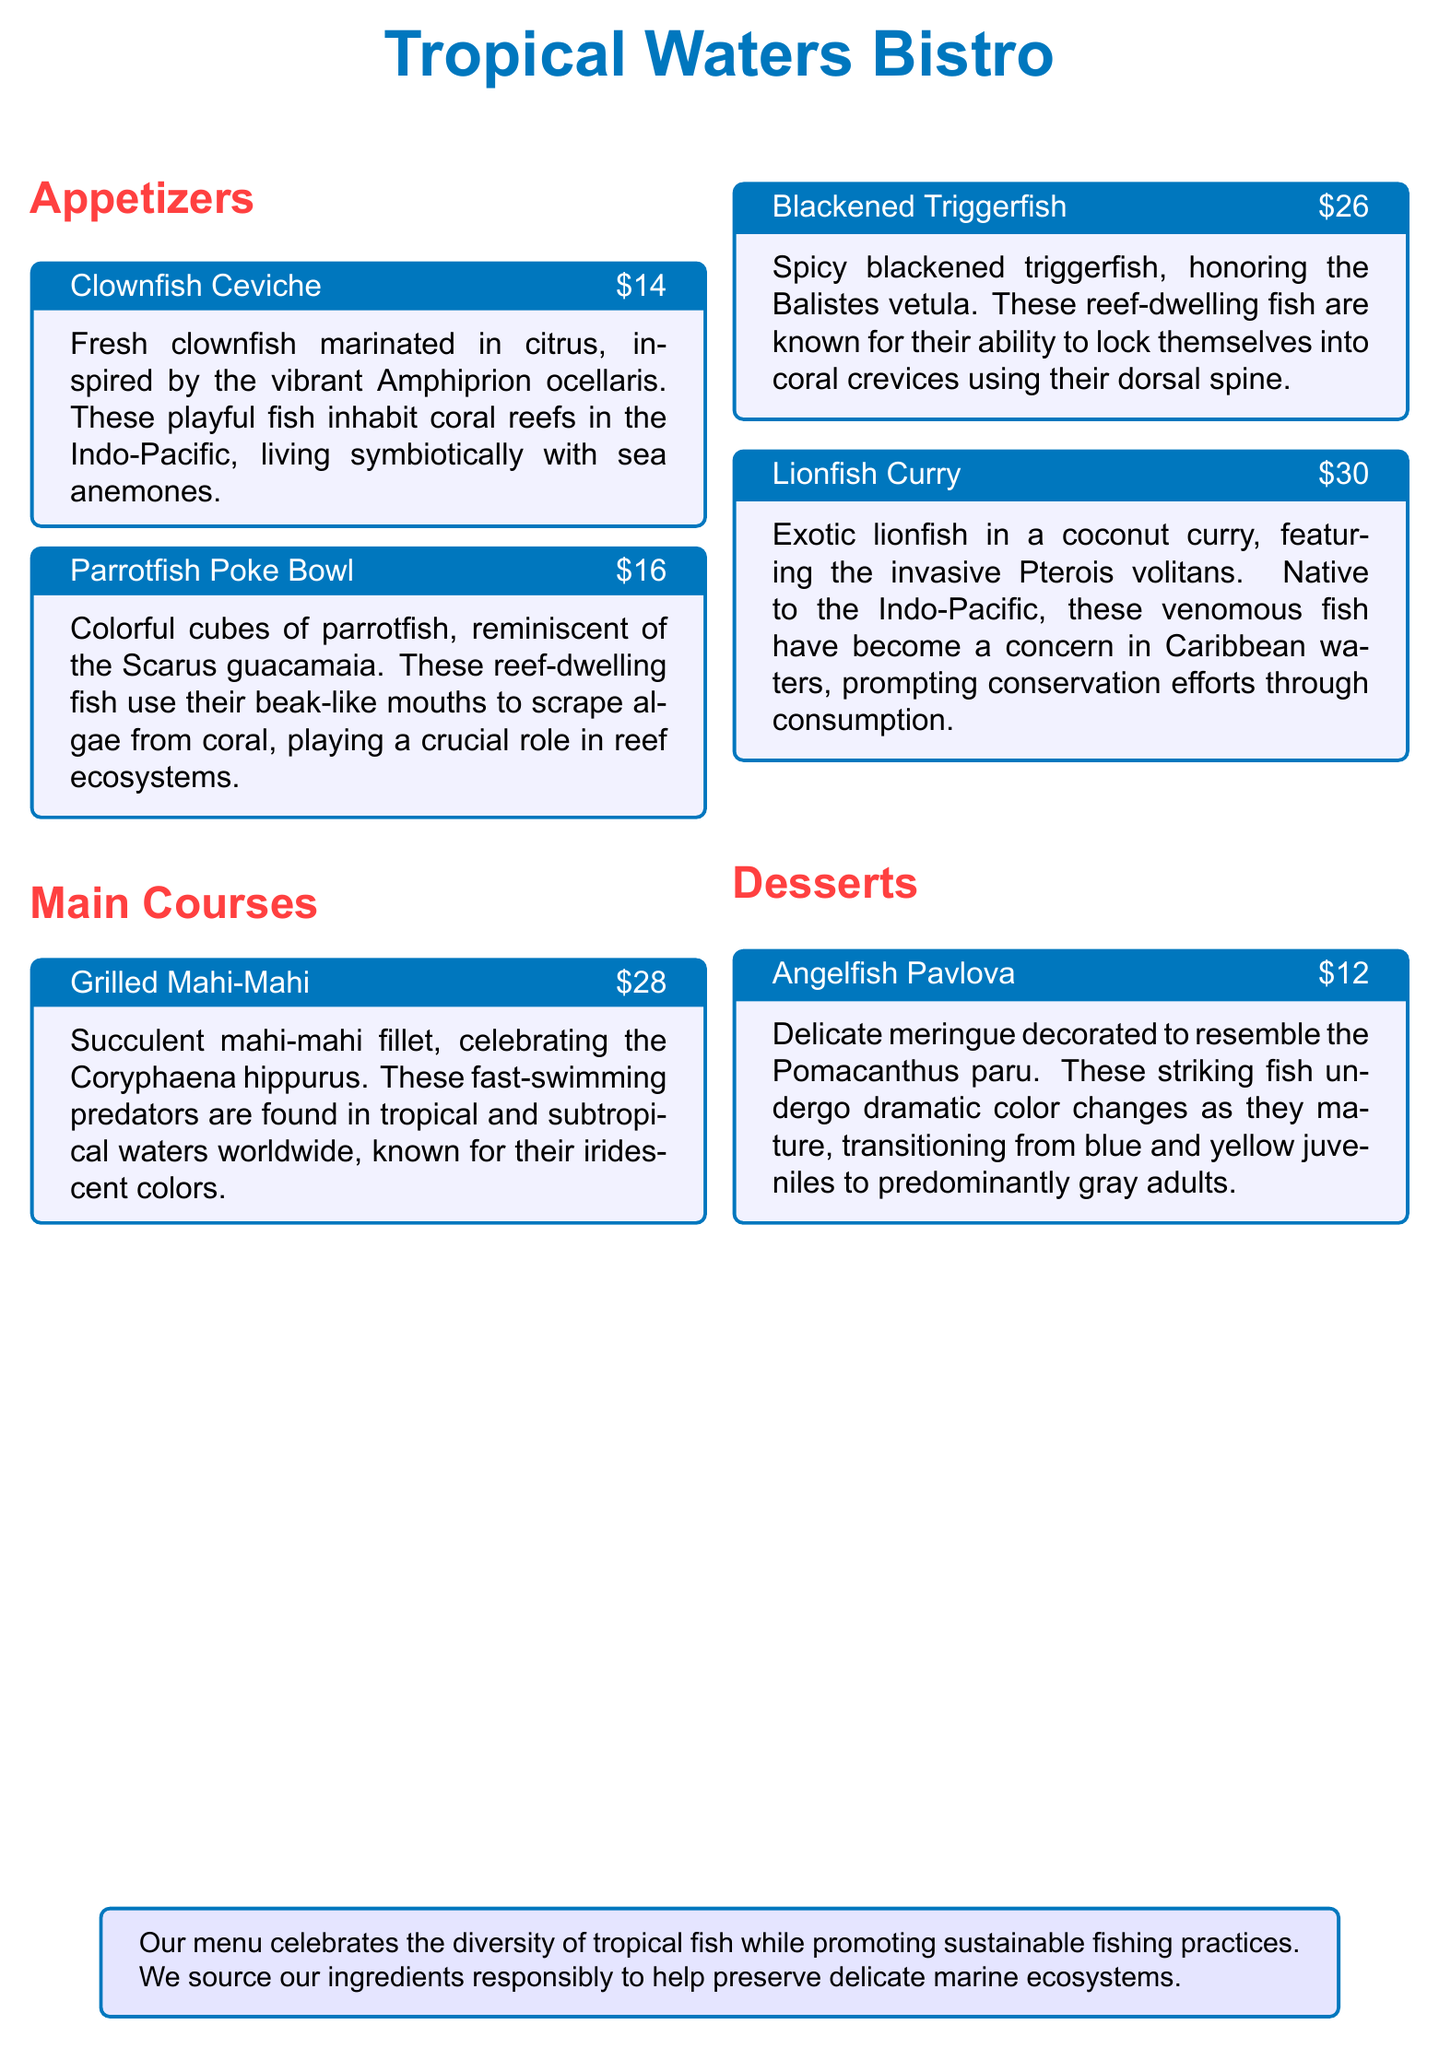What is the name of the seafood restaurant? The name of the restaurant is prominently displayed at the top of the document.
Answer: Tropical Waters Bistro How much does the Clownfish Ceviche cost? The cost of the Clownfish Ceviche is listed directly in the menu description.
Answer: $14 Which fish is featured in the Grilled Mahi-Mahi dish? The fish used in the dish is specified in the detailed description of the main course.
Answer: Coryphaena hippurus What unique behavior is attributed to the Triggerfish? The description highlights the behavior particular to the Balistes vetula within the menu.
Answer: Locking into coral crevices What is the main ingredient in the Lionfish Curry? The title and description of the dish indicate the primary ingredient used.
Answer: Lionfish Which category does the Angelfish Pavlova belong to? Categories are clearly indicated for each dish, distinguishing types of offerings.
Answer: Desserts What is the culinary approach of the restaurant regarding sourcing ingredients? The restaurant's philosophy can be found in the closing note of the document.
Answer: Sustainable fishing practices How many appetizers are listed on the menu? The number of appetizers can be counted based on the menu sections provided.
Answer: Two 